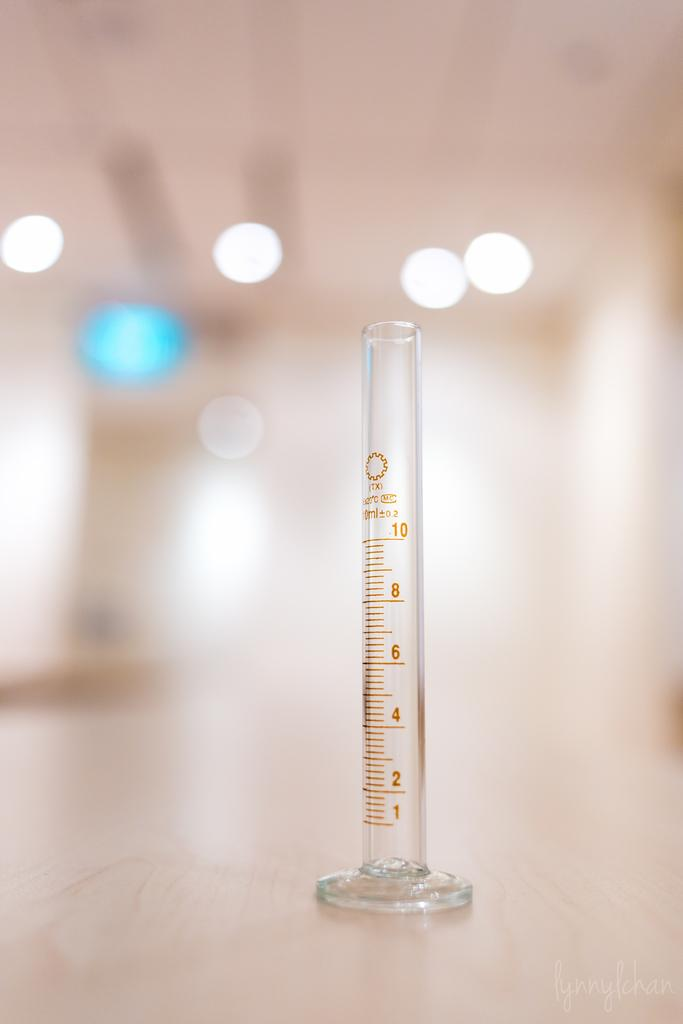<image>
Describe the image concisely. Measuring stick that go all the way up to ten 